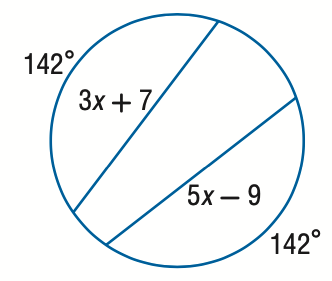Question: Find the value of x.
Choices:
A. 6
B. 7
C. 8
D. 9
Answer with the letter. Answer: C 